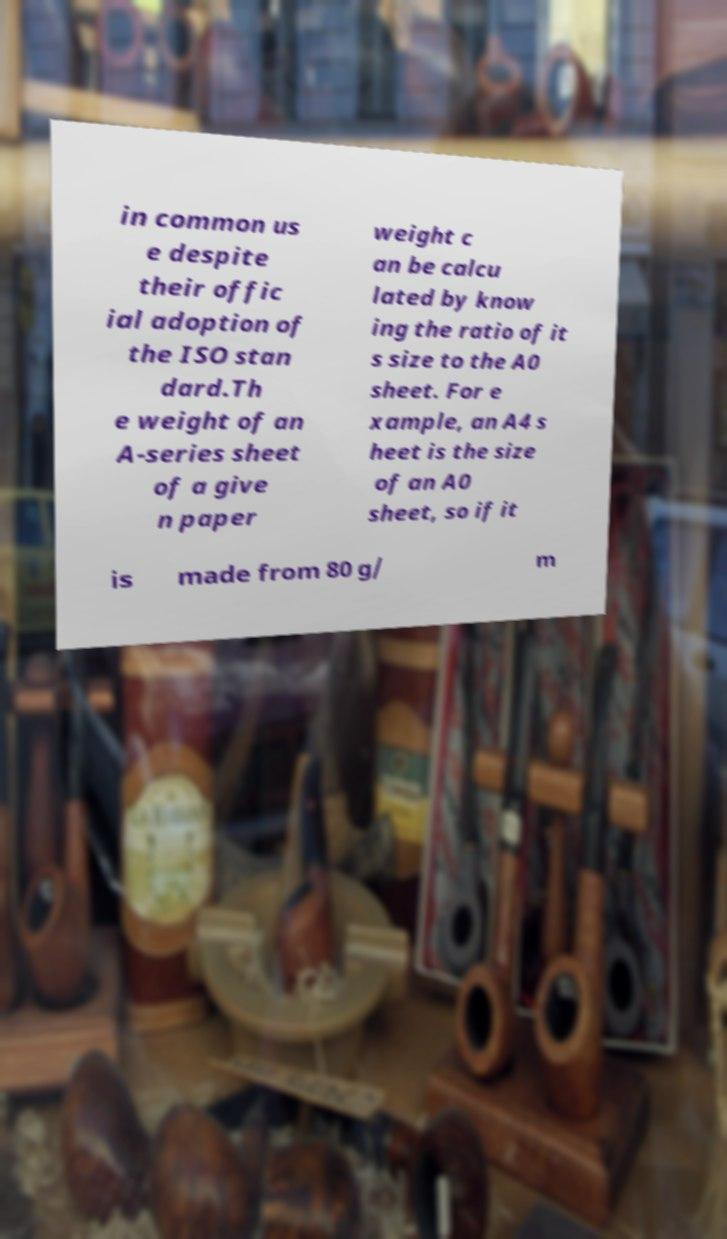Could you extract and type out the text from this image? in common us e despite their offic ial adoption of the ISO stan dard.Th e weight of an A-series sheet of a give n paper weight c an be calcu lated by know ing the ratio of it s size to the A0 sheet. For e xample, an A4 s heet is the size of an A0 sheet, so if it is made from 80 g/ m 